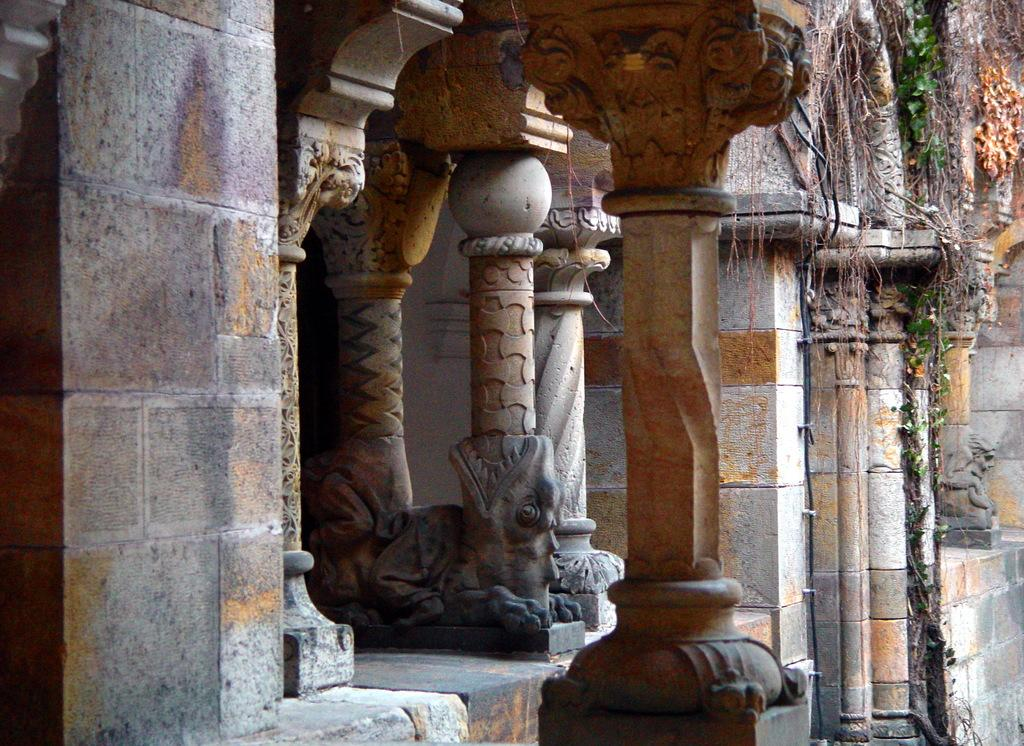What is a prominent feature in the image? There are many pillars in the image. What material are some of the pillars made of? Some pillars are made with bricks. What decorative elements can be seen on the pillars? There are sculptures on the pillars. What type of vegetation is present on the wall in the image? There are creepers on the wall on the right side of the image. What type of pin can be seen holding the sculpture in place on the pillar? There is no pin visible in the image; the sculptures are not held in place by any visible pins. 